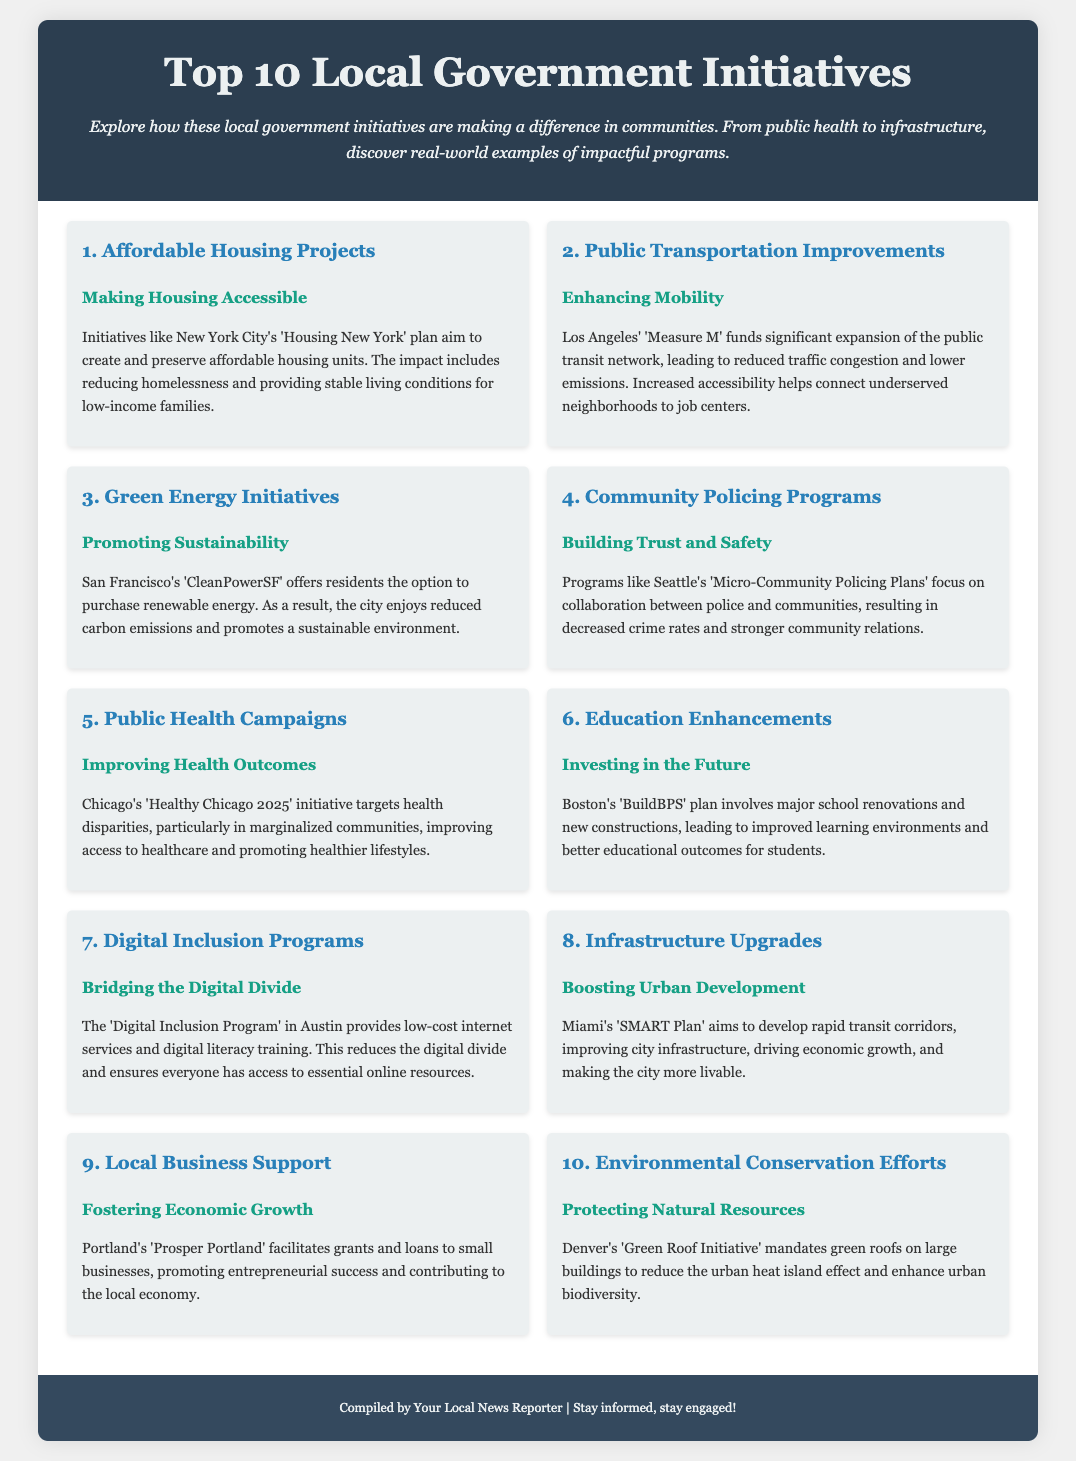What is the title of the infographic? The title is the main heading presented at the top of the document, introducing the content about initiatives.
Answer: Top 10 Local Government Initiatives What is the first initiative listed? The first initiative is the primary subject of the first block of information in the document.
Answer: Affordable Housing Projects Which city’s initiative is related to public transportation? The specific city is called out in the description of the second initiative regarding transportation improvements.
Answer: Los Angeles What does the 'Green Roof Initiative' in Denver aim to improve? The initiative's main goal is mentioned in the last initiative's description, highlighting what it seeks to address.
Answer: Urban biodiversity How many initiatives focus on health-related issues? The health-focused initiatives are counted by reviewing those specifically mentioning health in their descriptions.
Answer: Two Which initiative aims to bridge the digital divide? The initiative focusing on digital equality is explicitly named within the document's descriptions.
Answer: Digital Inclusion Programs What program does Seattle use for community policing? The program is mentioned as part of the fourth initiative and specifies its focus area.
Answer: Micro-Community Policing Plans How does Portland support local businesses? This method of support is outlined within the description of the ninth initiative.
Answer: Grants and loans 